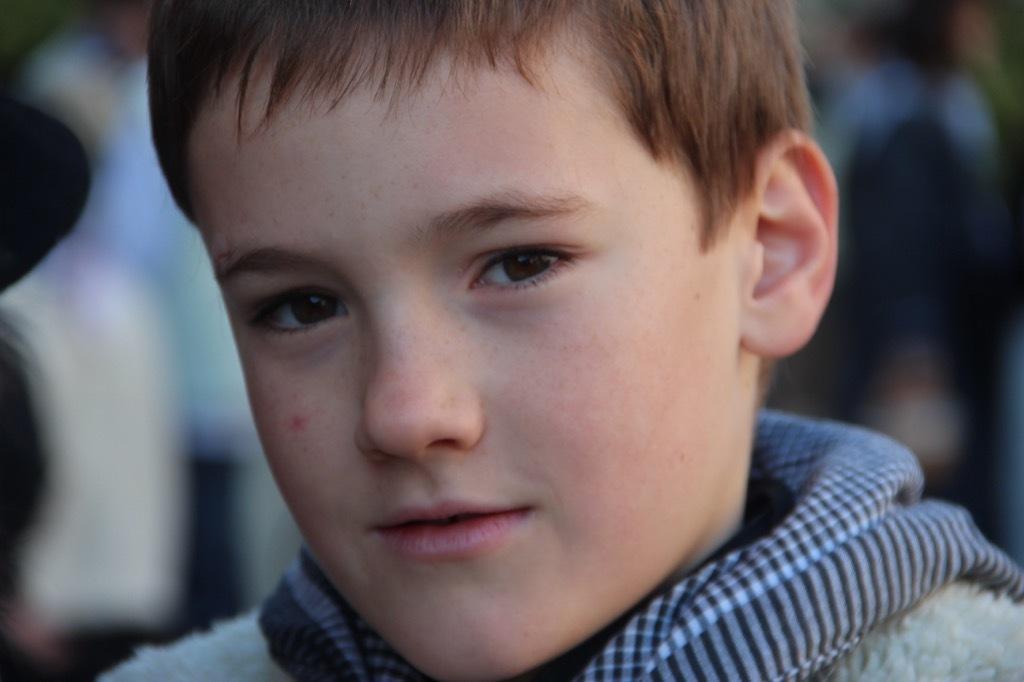Please provide a concise description of this image. As we can see in the image there is a boy smiling in the front. The background is blurred. 